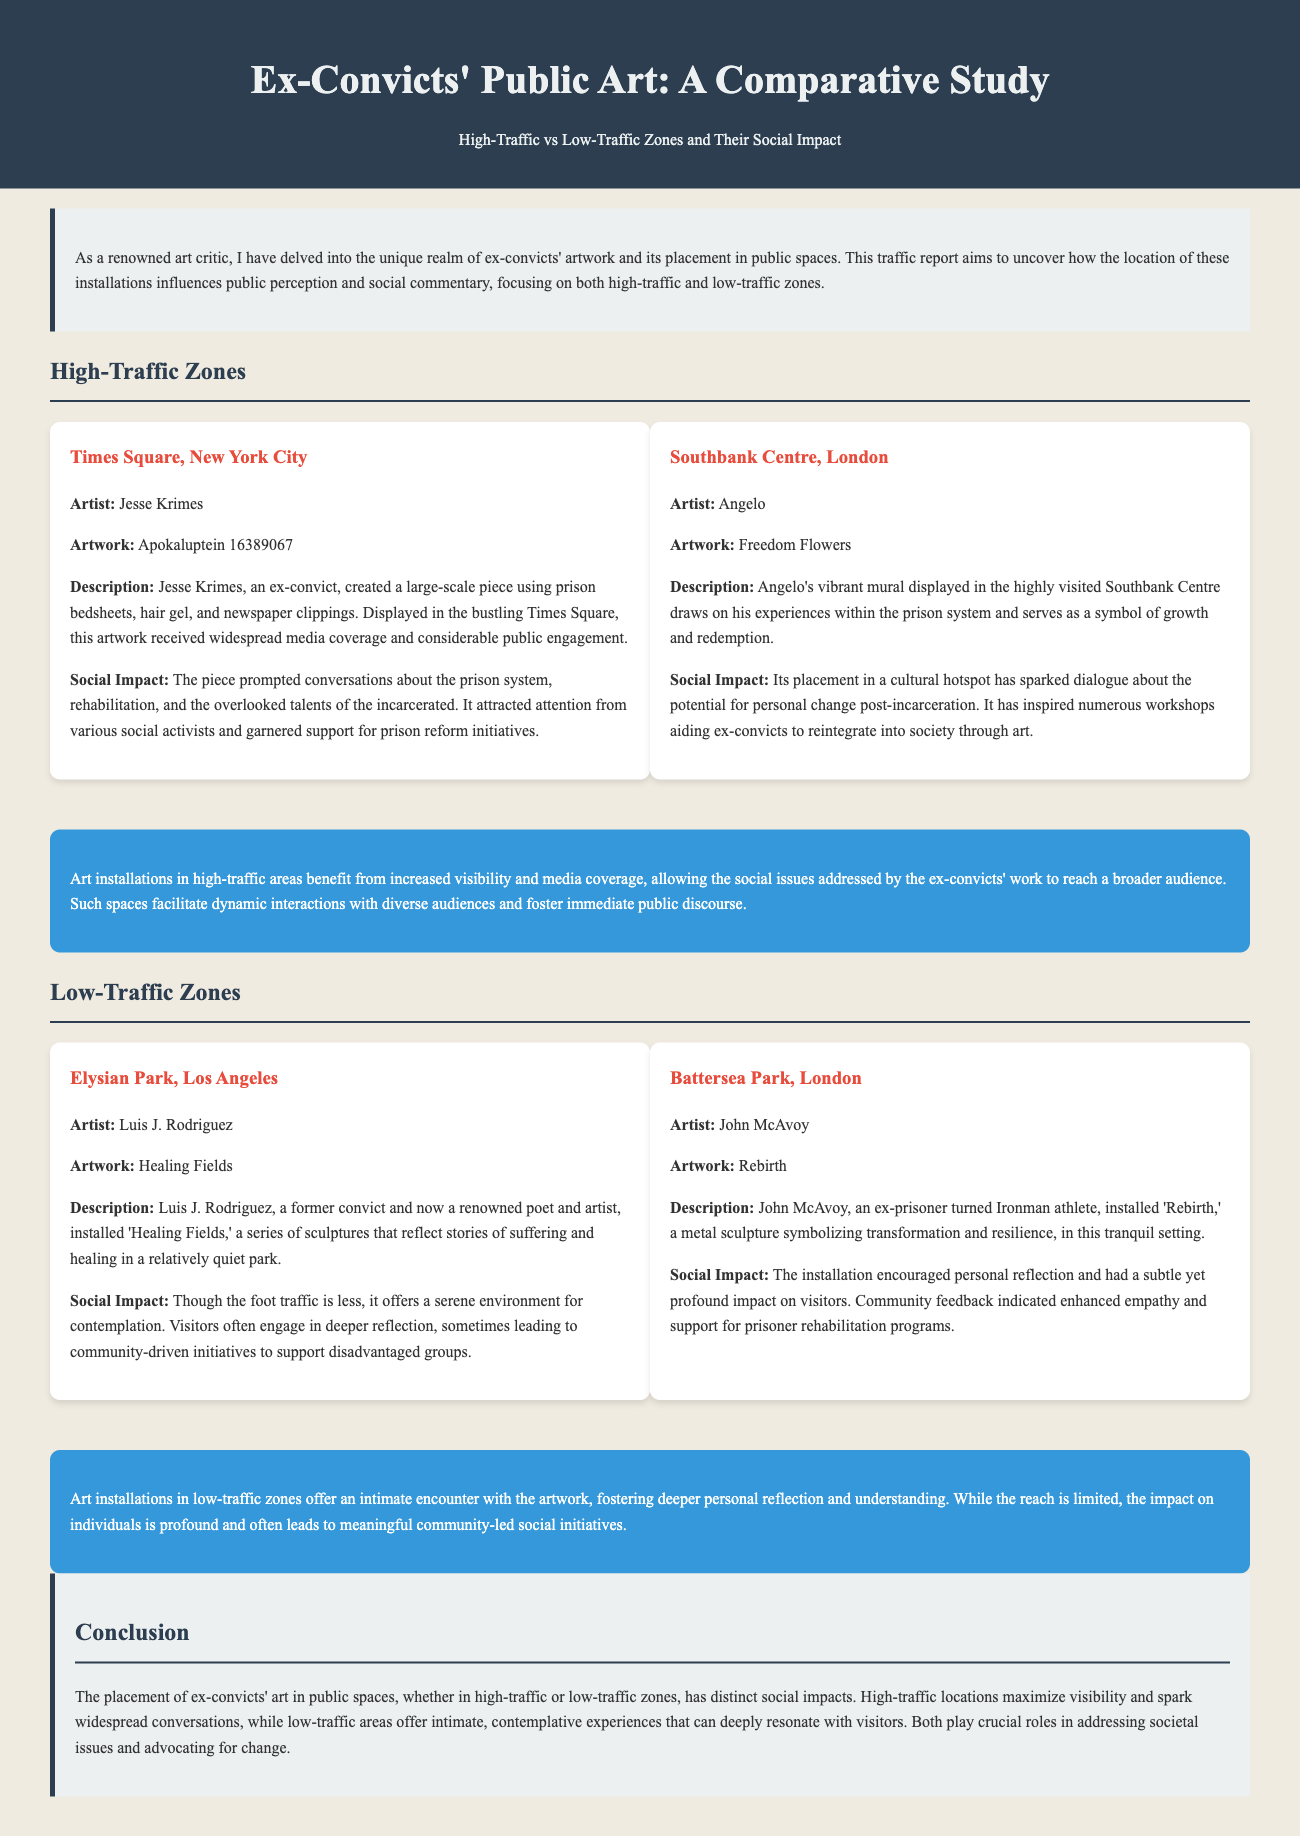What is the title of the artwork by Jesse Krimes? The title of the artwork by Jesse Krimes is mentioned as "Apokaluptein 16389067."
Answer: Apokaluptein 16389067 In which high-traffic location is Angelo's mural displayed? Angelo's mural "Freedom Flowers" is displayed in the highly visited Southbank Centre.
Answer: Southbank Centre What does Luis J. Rodriguez's installation "Healing Fields" reflect? "Healing Fields" reflects stories of suffering and healing.
Answer: Stories of suffering and healing What is the social impact of art in high-traffic areas according to the report? In high-traffic areas, the social impact includes increased visibility and public discourse about social issues.
Answer: Increased visibility and public discourse Which installation encourages personal reflection in a low-traffic zone? The installation "Rebirth" by John McAvoy encourages personal reflection in a low-traffic zone.
Answer: Rebirth How does the report classify the social impact of installations in low-traffic zones? The report states that installations in low-traffic zones lead to profound personal impact and community social initiatives.
Answer: Profound personal impact and community social initiatives What is the publication type of this document? The document is a traffic report that studies public art installations.
Answer: Traffic report 